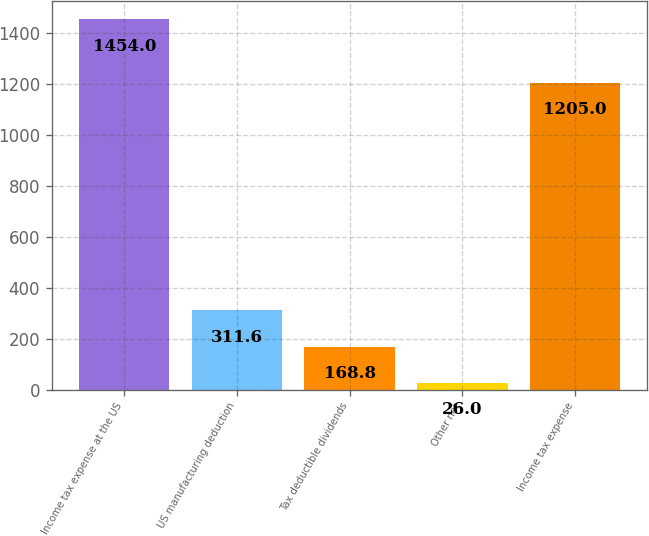<chart> <loc_0><loc_0><loc_500><loc_500><bar_chart><fcel>Income tax expense at the US<fcel>US manufacturing deduction<fcel>Tax deductible dividends<fcel>Other net<fcel>Income tax expense<nl><fcel>1454<fcel>311.6<fcel>168.8<fcel>26<fcel>1205<nl></chart> 